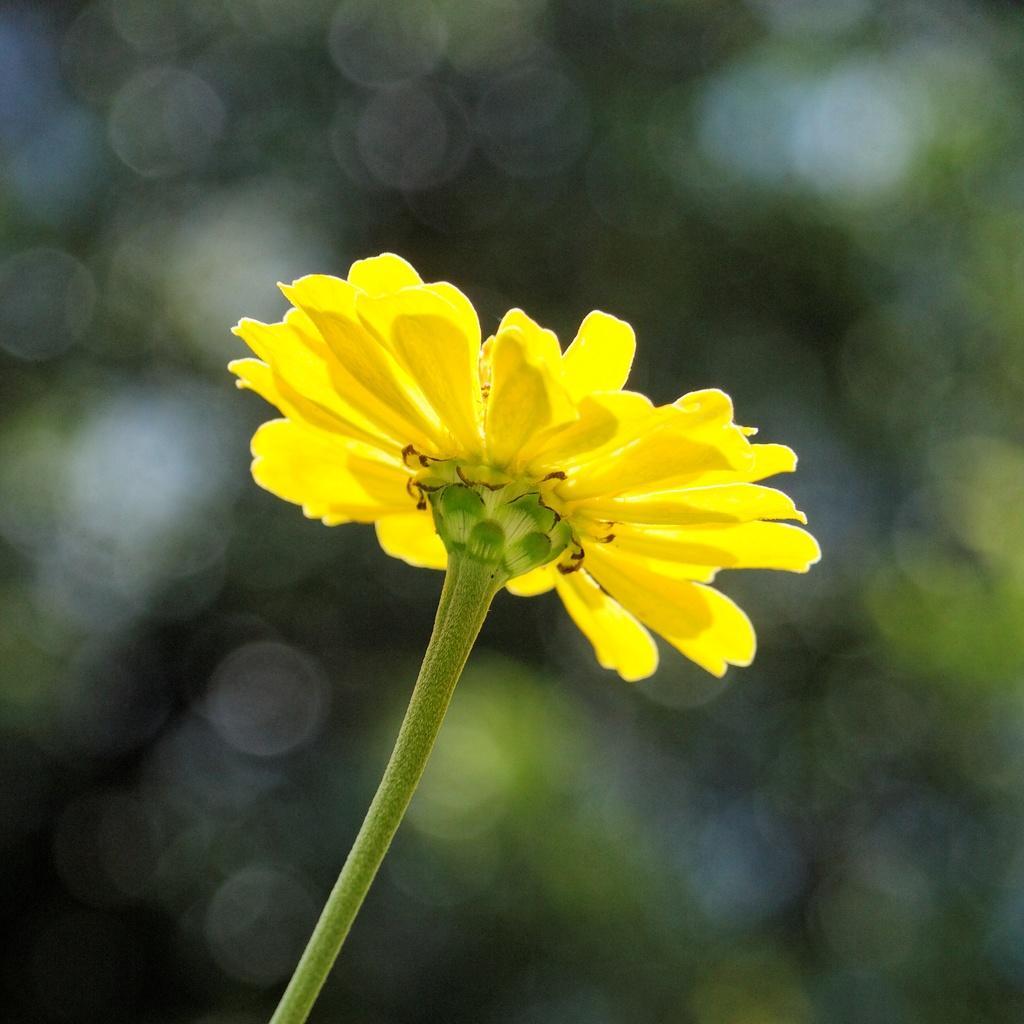How would you summarize this image in a sentence or two? In the center of the image we can see a flower. In the background the image is blur. 